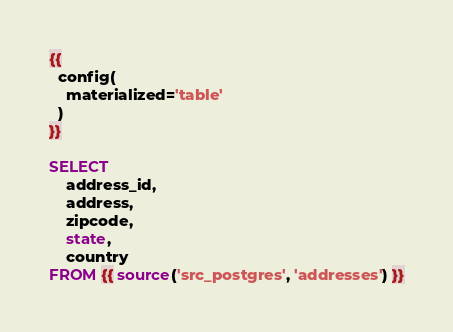Convert code to text. <code><loc_0><loc_0><loc_500><loc_500><_SQL_>{{
  config(
    materialized='table'
  )
}}

SELECT 
    address_id,
    address,
    zipcode,
    state,
    country
FROM {{ source('src_postgres', 'addresses') }}</code> 